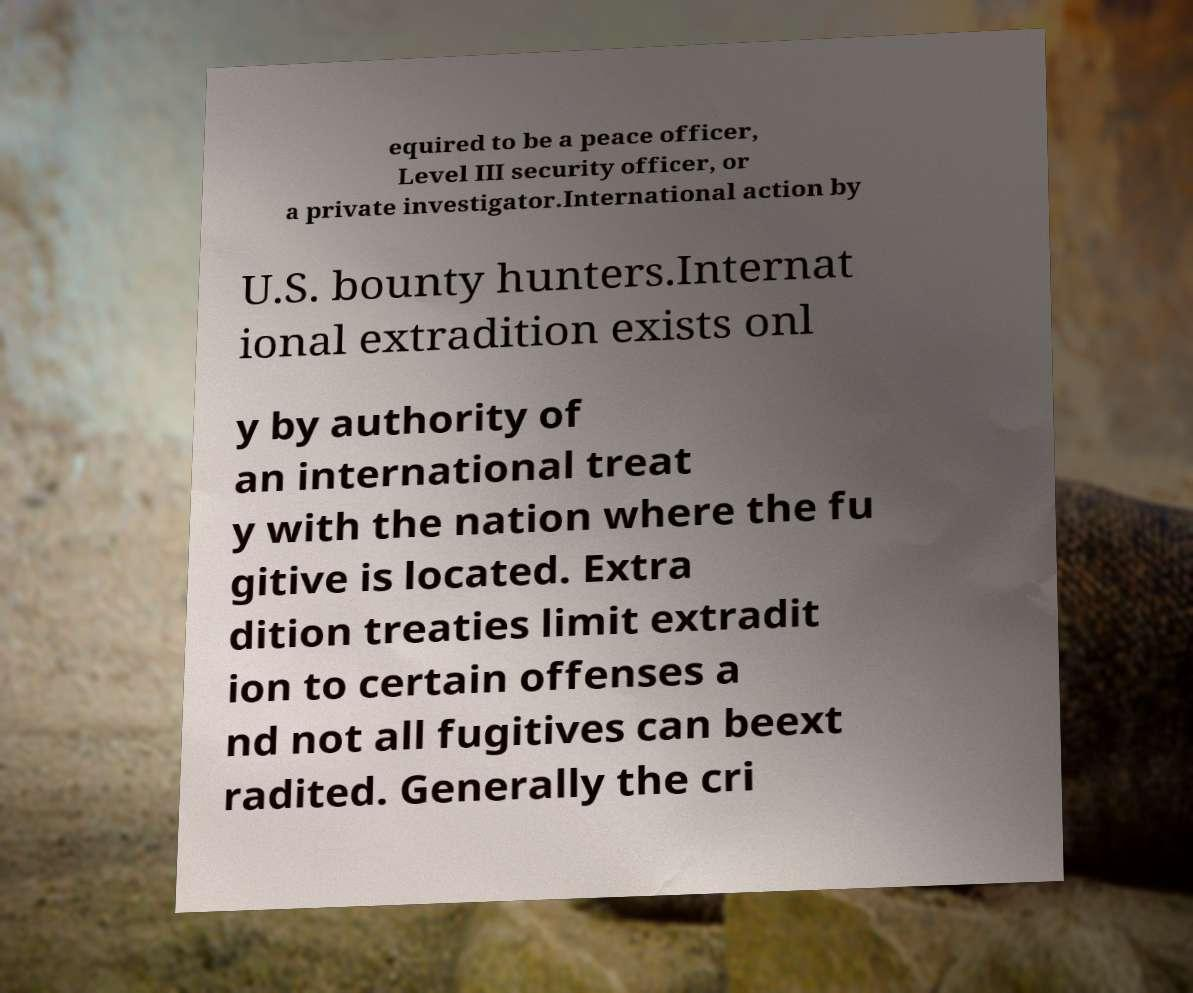Could you assist in decoding the text presented in this image and type it out clearly? equired to be a peace officer, Level III security officer, or a private investigator.International action by U.S. bounty hunters.Internat ional extradition exists onl y by authority of an international treat y with the nation where the fu gitive is located. Extra dition treaties limit extradit ion to certain offenses a nd not all fugitives can beext radited. Generally the cri 